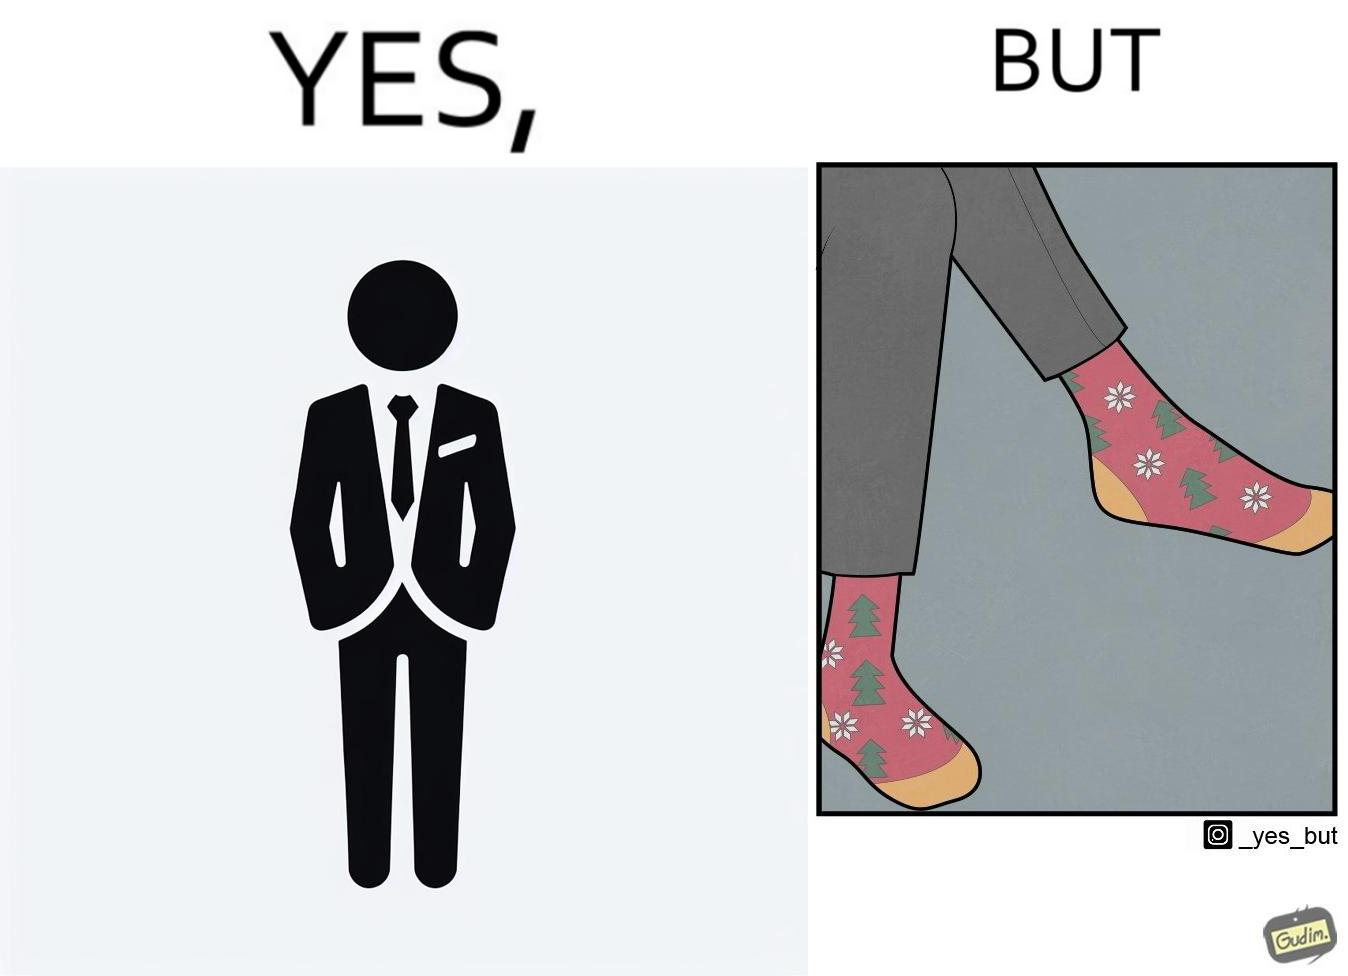Describe the content of this image. The image is ironical, as the person wearing a formal black suit and pants, is wearing colorful socks, probably due to the reason that socks are not visible while wearing shoes, and hence, do not need to be formal. 